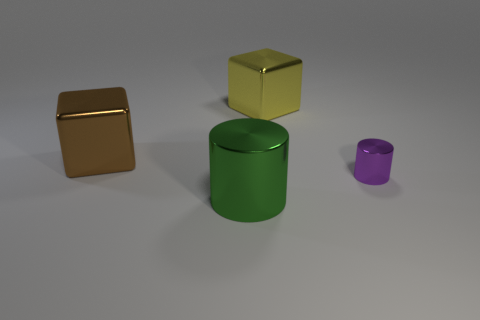Add 4 big red matte cylinders. How many objects exist? 8 Subtract all brown metal cubes. Subtract all brown shiny objects. How many objects are left? 2 Add 1 brown blocks. How many brown blocks are left? 2 Add 2 yellow shiny blocks. How many yellow shiny blocks exist? 3 Subtract 0 red cylinders. How many objects are left? 4 